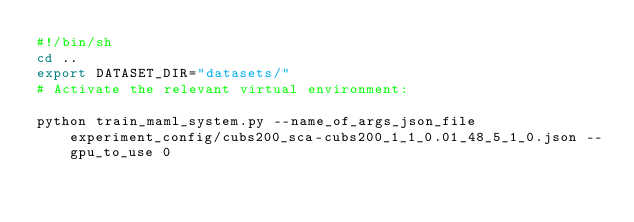Convert code to text. <code><loc_0><loc_0><loc_500><loc_500><_Bash_>#!/bin/sh
cd ..
export DATASET_DIR="datasets/"
# Activate the relevant virtual environment:

python train_maml_system.py --name_of_args_json_file experiment_config/cubs200_sca-cubs200_1_1_0.01_48_5_1_0.json --gpu_to_use 0</code> 